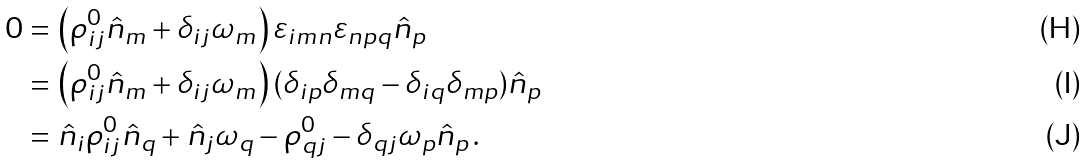Convert formula to latex. <formula><loc_0><loc_0><loc_500><loc_500>0 & = \left ( \rho ^ { 0 } _ { i j } \hat { n } _ { m } + \delta _ { i j } \omega _ { m } \right ) \varepsilon _ { i m n } \varepsilon _ { n p q } \hat { n } _ { p } \\ & = \left ( \rho ^ { 0 } _ { i j } \hat { n } _ { m } + \delta _ { i j } \omega _ { m } \right ) ( \delta _ { i p } \delta _ { m q } - \delta _ { i q } \delta _ { m p } ) \hat { n } _ { p } \\ & = \hat { n } _ { i } \rho ^ { 0 } _ { i j } \hat { n } _ { q } + \hat { n } _ { j } \omega _ { q } - \rho ^ { 0 } _ { q j } - \delta _ { q j } \omega _ { p } \hat { n } _ { p } \, .</formula> 